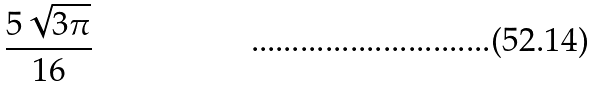Convert formula to latex. <formula><loc_0><loc_0><loc_500><loc_500>\frac { 5 \sqrt { 3 \pi } } { 1 6 }</formula> 